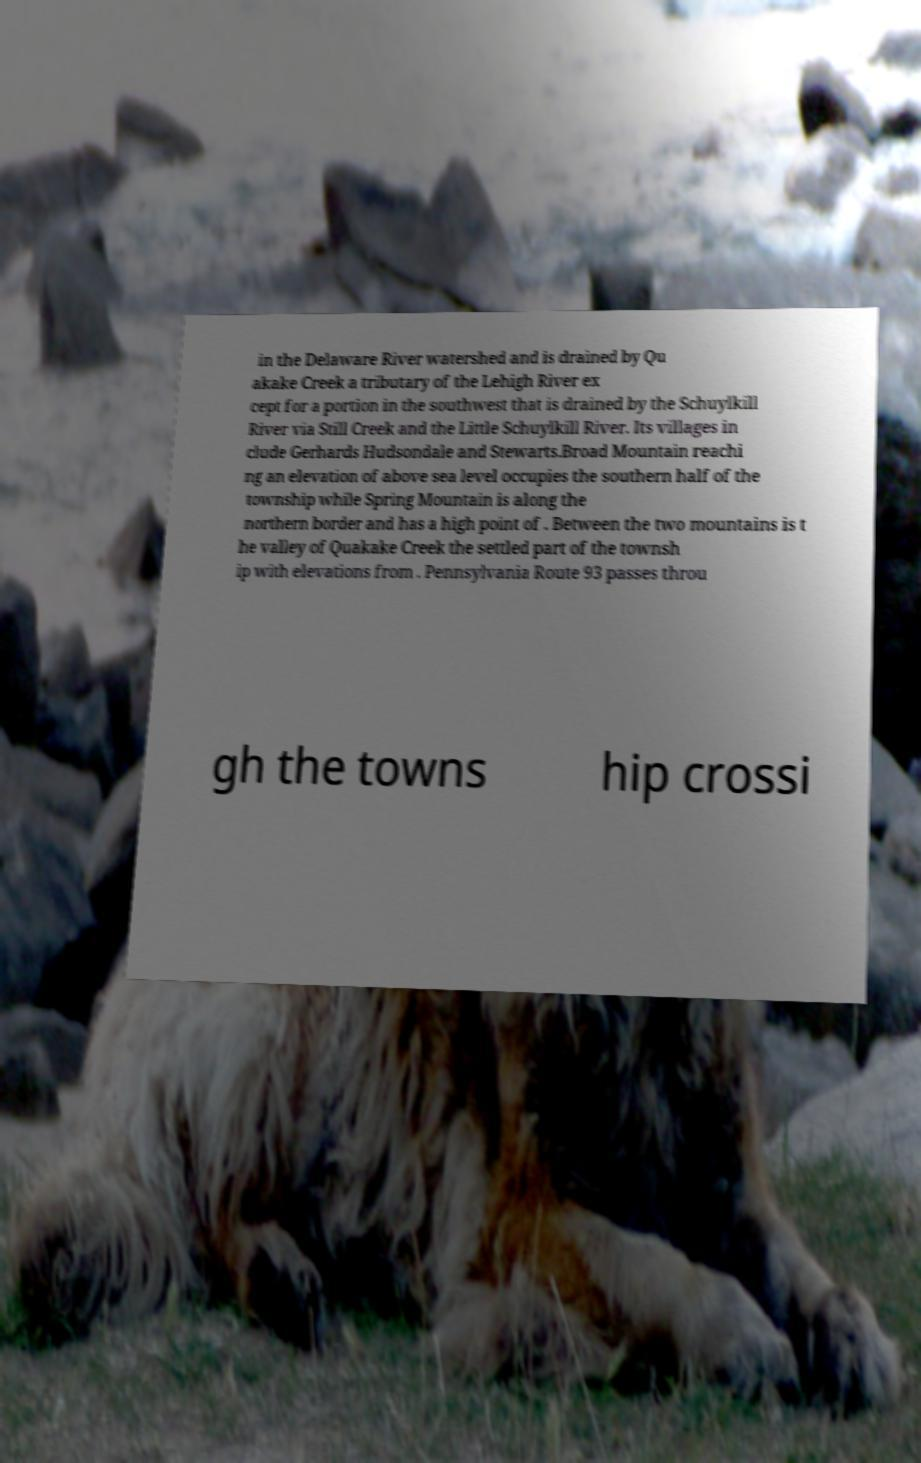Could you assist in decoding the text presented in this image and type it out clearly? in the Delaware River watershed and is drained by Qu akake Creek a tributary of the Lehigh River ex cept for a portion in the southwest that is drained by the Schuylkill River via Still Creek and the Little Schuylkill River. Its villages in clude Gerhards Hudsondale and Stewarts.Broad Mountain reachi ng an elevation of above sea level occupies the southern half of the township while Spring Mountain is along the northern border and has a high point of . Between the two mountains is t he valley of Quakake Creek the settled part of the townsh ip with elevations from . Pennsylvania Route 93 passes throu gh the towns hip crossi 